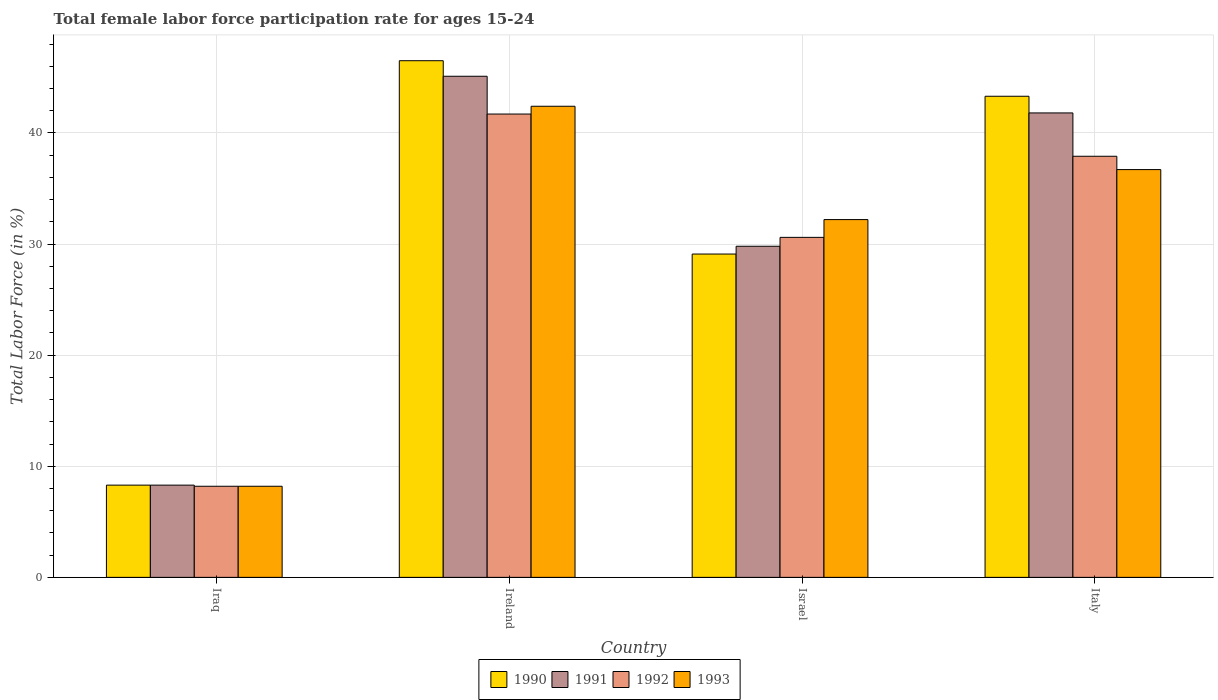Are the number of bars on each tick of the X-axis equal?
Provide a succinct answer. Yes. In how many cases, is the number of bars for a given country not equal to the number of legend labels?
Offer a terse response. 0. What is the female labor force participation rate in 1993 in Italy?
Ensure brevity in your answer.  36.7. Across all countries, what is the maximum female labor force participation rate in 1992?
Ensure brevity in your answer.  41.7. Across all countries, what is the minimum female labor force participation rate in 1992?
Provide a short and direct response. 8.2. In which country was the female labor force participation rate in 1993 maximum?
Your answer should be compact. Ireland. In which country was the female labor force participation rate in 1992 minimum?
Ensure brevity in your answer.  Iraq. What is the total female labor force participation rate in 1990 in the graph?
Make the answer very short. 127.2. What is the difference between the female labor force participation rate in 1990 in Ireland and that in Israel?
Offer a very short reply. 17.4. What is the difference between the female labor force participation rate in 1992 in Ireland and the female labor force participation rate in 1991 in Israel?
Make the answer very short. 11.9. What is the average female labor force participation rate in 1992 per country?
Give a very brief answer. 29.6. What is the difference between the female labor force participation rate of/in 1991 and female labor force participation rate of/in 1992 in Ireland?
Give a very brief answer. 3.4. In how many countries, is the female labor force participation rate in 1992 greater than 42 %?
Keep it short and to the point. 0. What is the ratio of the female labor force participation rate in 1992 in Ireland to that in Israel?
Offer a terse response. 1.36. Is the female labor force participation rate in 1991 in Iraq less than that in Ireland?
Give a very brief answer. Yes. Is the difference between the female labor force participation rate in 1991 in Ireland and Israel greater than the difference between the female labor force participation rate in 1992 in Ireland and Israel?
Offer a very short reply. Yes. What is the difference between the highest and the second highest female labor force participation rate in 1993?
Keep it short and to the point. -10.2. What is the difference between the highest and the lowest female labor force participation rate in 1993?
Ensure brevity in your answer.  34.2. Is the sum of the female labor force participation rate in 1990 in Israel and Italy greater than the maximum female labor force participation rate in 1991 across all countries?
Your response must be concise. Yes. Is it the case that in every country, the sum of the female labor force participation rate in 1992 and female labor force participation rate in 1993 is greater than the sum of female labor force participation rate in 1990 and female labor force participation rate in 1991?
Provide a short and direct response. No. What does the 1st bar from the right in Italy represents?
Keep it short and to the point. 1993. Does the graph contain grids?
Provide a short and direct response. Yes. Where does the legend appear in the graph?
Your answer should be very brief. Bottom center. How many legend labels are there?
Make the answer very short. 4. What is the title of the graph?
Keep it short and to the point. Total female labor force participation rate for ages 15-24. What is the label or title of the X-axis?
Give a very brief answer. Country. What is the Total Labor Force (in %) of 1990 in Iraq?
Your answer should be compact. 8.3. What is the Total Labor Force (in %) in 1991 in Iraq?
Make the answer very short. 8.3. What is the Total Labor Force (in %) of 1992 in Iraq?
Your response must be concise. 8.2. What is the Total Labor Force (in %) of 1993 in Iraq?
Your response must be concise. 8.2. What is the Total Labor Force (in %) of 1990 in Ireland?
Your answer should be very brief. 46.5. What is the Total Labor Force (in %) in 1991 in Ireland?
Keep it short and to the point. 45.1. What is the Total Labor Force (in %) in 1992 in Ireland?
Provide a succinct answer. 41.7. What is the Total Labor Force (in %) in 1993 in Ireland?
Give a very brief answer. 42.4. What is the Total Labor Force (in %) in 1990 in Israel?
Provide a succinct answer. 29.1. What is the Total Labor Force (in %) in 1991 in Israel?
Your response must be concise. 29.8. What is the Total Labor Force (in %) of 1992 in Israel?
Your response must be concise. 30.6. What is the Total Labor Force (in %) in 1993 in Israel?
Provide a short and direct response. 32.2. What is the Total Labor Force (in %) in 1990 in Italy?
Keep it short and to the point. 43.3. What is the Total Labor Force (in %) of 1991 in Italy?
Your answer should be compact. 41.8. What is the Total Labor Force (in %) of 1992 in Italy?
Your answer should be very brief. 37.9. What is the Total Labor Force (in %) of 1993 in Italy?
Offer a terse response. 36.7. Across all countries, what is the maximum Total Labor Force (in %) in 1990?
Your answer should be compact. 46.5. Across all countries, what is the maximum Total Labor Force (in %) in 1991?
Provide a succinct answer. 45.1. Across all countries, what is the maximum Total Labor Force (in %) in 1992?
Your response must be concise. 41.7. Across all countries, what is the maximum Total Labor Force (in %) of 1993?
Your answer should be compact. 42.4. Across all countries, what is the minimum Total Labor Force (in %) of 1990?
Ensure brevity in your answer.  8.3. Across all countries, what is the minimum Total Labor Force (in %) in 1991?
Offer a terse response. 8.3. Across all countries, what is the minimum Total Labor Force (in %) of 1992?
Offer a terse response. 8.2. Across all countries, what is the minimum Total Labor Force (in %) of 1993?
Keep it short and to the point. 8.2. What is the total Total Labor Force (in %) of 1990 in the graph?
Ensure brevity in your answer.  127.2. What is the total Total Labor Force (in %) of 1991 in the graph?
Keep it short and to the point. 125. What is the total Total Labor Force (in %) of 1992 in the graph?
Make the answer very short. 118.4. What is the total Total Labor Force (in %) in 1993 in the graph?
Your answer should be compact. 119.5. What is the difference between the Total Labor Force (in %) in 1990 in Iraq and that in Ireland?
Keep it short and to the point. -38.2. What is the difference between the Total Labor Force (in %) of 1991 in Iraq and that in Ireland?
Offer a terse response. -36.8. What is the difference between the Total Labor Force (in %) in 1992 in Iraq and that in Ireland?
Provide a short and direct response. -33.5. What is the difference between the Total Labor Force (in %) in 1993 in Iraq and that in Ireland?
Provide a succinct answer. -34.2. What is the difference between the Total Labor Force (in %) in 1990 in Iraq and that in Israel?
Make the answer very short. -20.8. What is the difference between the Total Labor Force (in %) of 1991 in Iraq and that in Israel?
Offer a very short reply. -21.5. What is the difference between the Total Labor Force (in %) of 1992 in Iraq and that in Israel?
Offer a very short reply. -22.4. What is the difference between the Total Labor Force (in %) in 1990 in Iraq and that in Italy?
Your response must be concise. -35. What is the difference between the Total Labor Force (in %) in 1991 in Iraq and that in Italy?
Your response must be concise. -33.5. What is the difference between the Total Labor Force (in %) in 1992 in Iraq and that in Italy?
Give a very brief answer. -29.7. What is the difference between the Total Labor Force (in %) in 1993 in Iraq and that in Italy?
Keep it short and to the point. -28.5. What is the difference between the Total Labor Force (in %) of 1990 in Ireland and that in Israel?
Your answer should be compact. 17.4. What is the difference between the Total Labor Force (in %) in 1991 in Ireland and that in Israel?
Keep it short and to the point. 15.3. What is the difference between the Total Labor Force (in %) of 1990 in Ireland and that in Italy?
Provide a short and direct response. 3.2. What is the difference between the Total Labor Force (in %) of 1993 in Ireland and that in Italy?
Ensure brevity in your answer.  5.7. What is the difference between the Total Labor Force (in %) of 1990 in Israel and that in Italy?
Make the answer very short. -14.2. What is the difference between the Total Labor Force (in %) in 1992 in Israel and that in Italy?
Offer a terse response. -7.3. What is the difference between the Total Labor Force (in %) of 1993 in Israel and that in Italy?
Your response must be concise. -4.5. What is the difference between the Total Labor Force (in %) in 1990 in Iraq and the Total Labor Force (in %) in 1991 in Ireland?
Provide a short and direct response. -36.8. What is the difference between the Total Labor Force (in %) of 1990 in Iraq and the Total Labor Force (in %) of 1992 in Ireland?
Make the answer very short. -33.4. What is the difference between the Total Labor Force (in %) in 1990 in Iraq and the Total Labor Force (in %) in 1993 in Ireland?
Your answer should be compact. -34.1. What is the difference between the Total Labor Force (in %) of 1991 in Iraq and the Total Labor Force (in %) of 1992 in Ireland?
Your response must be concise. -33.4. What is the difference between the Total Labor Force (in %) of 1991 in Iraq and the Total Labor Force (in %) of 1993 in Ireland?
Your answer should be very brief. -34.1. What is the difference between the Total Labor Force (in %) in 1992 in Iraq and the Total Labor Force (in %) in 1993 in Ireland?
Give a very brief answer. -34.2. What is the difference between the Total Labor Force (in %) in 1990 in Iraq and the Total Labor Force (in %) in 1991 in Israel?
Your answer should be very brief. -21.5. What is the difference between the Total Labor Force (in %) of 1990 in Iraq and the Total Labor Force (in %) of 1992 in Israel?
Your answer should be very brief. -22.3. What is the difference between the Total Labor Force (in %) of 1990 in Iraq and the Total Labor Force (in %) of 1993 in Israel?
Keep it short and to the point. -23.9. What is the difference between the Total Labor Force (in %) in 1991 in Iraq and the Total Labor Force (in %) in 1992 in Israel?
Offer a very short reply. -22.3. What is the difference between the Total Labor Force (in %) of 1991 in Iraq and the Total Labor Force (in %) of 1993 in Israel?
Provide a short and direct response. -23.9. What is the difference between the Total Labor Force (in %) of 1992 in Iraq and the Total Labor Force (in %) of 1993 in Israel?
Make the answer very short. -24. What is the difference between the Total Labor Force (in %) in 1990 in Iraq and the Total Labor Force (in %) in 1991 in Italy?
Give a very brief answer. -33.5. What is the difference between the Total Labor Force (in %) of 1990 in Iraq and the Total Labor Force (in %) of 1992 in Italy?
Give a very brief answer. -29.6. What is the difference between the Total Labor Force (in %) in 1990 in Iraq and the Total Labor Force (in %) in 1993 in Italy?
Provide a short and direct response. -28.4. What is the difference between the Total Labor Force (in %) in 1991 in Iraq and the Total Labor Force (in %) in 1992 in Italy?
Provide a succinct answer. -29.6. What is the difference between the Total Labor Force (in %) of 1991 in Iraq and the Total Labor Force (in %) of 1993 in Italy?
Give a very brief answer. -28.4. What is the difference between the Total Labor Force (in %) of 1992 in Iraq and the Total Labor Force (in %) of 1993 in Italy?
Offer a very short reply. -28.5. What is the difference between the Total Labor Force (in %) of 1991 in Ireland and the Total Labor Force (in %) of 1993 in Israel?
Offer a terse response. 12.9. What is the difference between the Total Labor Force (in %) of 1990 in Ireland and the Total Labor Force (in %) of 1991 in Italy?
Give a very brief answer. 4.7. What is the difference between the Total Labor Force (in %) in 1990 in Ireland and the Total Labor Force (in %) in 1992 in Italy?
Your answer should be compact. 8.6. What is the difference between the Total Labor Force (in %) of 1990 in Ireland and the Total Labor Force (in %) of 1993 in Italy?
Keep it short and to the point. 9.8. What is the difference between the Total Labor Force (in %) in 1991 in Ireland and the Total Labor Force (in %) in 1993 in Italy?
Provide a short and direct response. 8.4. What is the difference between the Total Labor Force (in %) of 1990 in Israel and the Total Labor Force (in %) of 1991 in Italy?
Your response must be concise. -12.7. What is the difference between the Total Labor Force (in %) of 1991 in Israel and the Total Labor Force (in %) of 1993 in Italy?
Keep it short and to the point. -6.9. What is the difference between the Total Labor Force (in %) in 1992 in Israel and the Total Labor Force (in %) in 1993 in Italy?
Your answer should be very brief. -6.1. What is the average Total Labor Force (in %) in 1990 per country?
Provide a succinct answer. 31.8. What is the average Total Labor Force (in %) of 1991 per country?
Your answer should be very brief. 31.25. What is the average Total Labor Force (in %) in 1992 per country?
Offer a very short reply. 29.6. What is the average Total Labor Force (in %) in 1993 per country?
Offer a very short reply. 29.88. What is the difference between the Total Labor Force (in %) in 1990 and Total Labor Force (in %) in 1991 in Iraq?
Your response must be concise. 0. What is the difference between the Total Labor Force (in %) of 1991 and Total Labor Force (in %) of 1993 in Iraq?
Make the answer very short. 0.1. What is the difference between the Total Labor Force (in %) in 1992 and Total Labor Force (in %) in 1993 in Iraq?
Ensure brevity in your answer.  0. What is the difference between the Total Labor Force (in %) in 1990 and Total Labor Force (in %) in 1992 in Ireland?
Ensure brevity in your answer.  4.8. What is the difference between the Total Labor Force (in %) in 1990 and Total Labor Force (in %) in 1993 in Ireland?
Provide a succinct answer. 4.1. What is the difference between the Total Labor Force (in %) of 1991 and Total Labor Force (in %) of 1993 in Ireland?
Provide a short and direct response. 2.7. What is the difference between the Total Labor Force (in %) of 1992 and Total Labor Force (in %) of 1993 in Ireland?
Provide a short and direct response. -0.7. What is the difference between the Total Labor Force (in %) of 1990 and Total Labor Force (in %) of 1991 in Israel?
Your answer should be very brief. -0.7. What is the difference between the Total Labor Force (in %) of 1990 and Total Labor Force (in %) of 1992 in Israel?
Keep it short and to the point. -1.5. What is the difference between the Total Labor Force (in %) in 1990 and Total Labor Force (in %) in 1993 in Israel?
Offer a very short reply. -3.1. What is the difference between the Total Labor Force (in %) in 1991 and Total Labor Force (in %) in 1992 in Italy?
Make the answer very short. 3.9. What is the ratio of the Total Labor Force (in %) in 1990 in Iraq to that in Ireland?
Make the answer very short. 0.18. What is the ratio of the Total Labor Force (in %) in 1991 in Iraq to that in Ireland?
Provide a succinct answer. 0.18. What is the ratio of the Total Labor Force (in %) in 1992 in Iraq to that in Ireland?
Provide a short and direct response. 0.2. What is the ratio of the Total Labor Force (in %) in 1993 in Iraq to that in Ireland?
Keep it short and to the point. 0.19. What is the ratio of the Total Labor Force (in %) of 1990 in Iraq to that in Israel?
Provide a succinct answer. 0.29. What is the ratio of the Total Labor Force (in %) of 1991 in Iraq to that in Israel?
Give a very brief answer. 0.28. What is the ratio of the Total Labor Force (in %) in 1992 in Iraq to that in Israel?
Provide a short and direct response. 0.27. What is the ratio of the Total Labor Force (in %) of 1993 in Iraq to that in Israel?
Provide a short and direct response. 0.25. What is the ratio of the Total Labor Force (in %) in 1990 in Iraq to that in Italy?
Provide a succinct answer. 0.19. What is the ratio of the Total Labor Force (in %) of 1991 in Iraq to that in Italy?
Ensure brevity in your answer.  0.2. What is the ratio of the Total Labor Force (in %) of 1992 in Iraq to that in Italy?
Provide a succinct answer. 0.22. What is the ratio of the Total Labor Force (in %) of 1993 in Iraq to that in Italy?
Provide a short and direct response. 0.22. What is the ratio of the Total Labor Force (in %) in 1990 in Ireland to that in Israel?
Offer a very short reply. 1.6. What is the ratio of the Total Labor Force (in %) of 1991 in Ireland to that in Israel?
Your answer should be compact. 1.51. What is the ratio of the Total Labor Force (in %) of 1992 in Ireland to that in Israel?
Make the answer very short. 1.36. What is the ratio of the Total Labor Force (in %) in 1993 in Ireland to that in Israel?
Your response must be concise. 1.32. What is the ratio of the Total Labor Force (in %) of 1990 in Ireland to that in Italy?
Make the answer very short. 1.07. What is the ratio of the Total Labor Force (in %) in 1991 in Ireland to that in Italy?
Provide a short and direct response. 1.08. What is the ratio of the Total Labor Force (in %) in 1992 in Ireland to that in Italy?
Offer a very short reply. 1.1. What is the ratio of the Total Labor Force (in %) in 1993 in Ireland to that in Italy?
Your answer should be compact. 1.16. What is the ratio of the Total Labor Force (in %) in 1990 in Israel to that in Italy?
Provide a succinct answer. 0.67. What is the ratio of the Total Labor Force (in %) in 1991 in Israel to that in Italy?
Make the answer very short. 0.71. What is the ratio of the Total Labor Force (in %) of 1992 in Israel to that in Italy?
Offer a very short reply. 0.81. What is the ratio of the Total Labor Force (in %) in 1993 in Israel to that in Italy?
Offer a very short reply. 0.88. What is the difference between the highest and the second highest Total Labor Force (in %) in 1991?
Make the answer very short. 3.3. What is the difference between the highest and the second highest Total Labor Force (in %) of 1993?
Keep it short and to the point. 5.7. What is the difference between the highest and the lowest Total Labor Force (in %) in 1990?
Make the answer very short. 38.2. What is the difference between the highest and the lowest Total Labor Force (in %) in 1991?
Offer a very short reply. 36.8. What is the difference between the highest and the lowest Total Labor Force (in %) of 1992?
Ensure brevity in your answer.  33.5. What is the difference between the highest and the lowest Total Labor Force (in %) of 1993?
Provide a succinct answer. 34.2. 